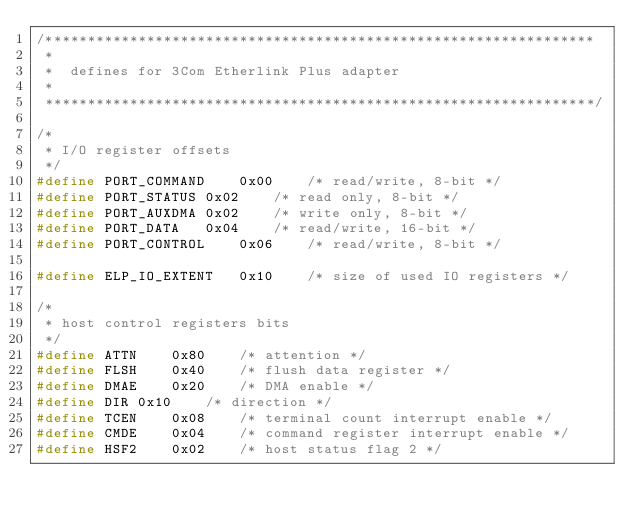Convert code to text. <code><loc_0><loc_0><loc_500><loc_500><_C_>/*****************************************************************
 *
 *  defines for 3Com Etherlink Plus adapter
 *
 *****************************************************************/

/*
 * I/O register offsets
 */
#define	PORT_COMMAND	0x00	/* read/write, 8-bit */
#define	PORT_STATUS	0x02	/* read only, 8-bit */
#define	PORT_AUXDMA	0x02	/* write only, 8-bit */
#define	PORT_DATA	0x04	/* read/write, 16-bit */
#define	PORT_CONTROL	0x06	/* read/write, 8-bit */

#define ELP_IO_EXTENT	0x10	/* size of used IO registers */

/*
 * host control registers bits
 */
#define	ATTN	0x80	/* attention */
#define	FLSH	0x40	/* flush data register */
#define DMAE	0x20	/* DMA enable */
#define DIR	0x10	/* direction */
#define	TCEN	0x08	/* terminal count interrupt enable */
#define	CMDE	0x04	/* command register interrupt enable */
#define	HSF2	0x02	/* host status flag 2 */</code> 